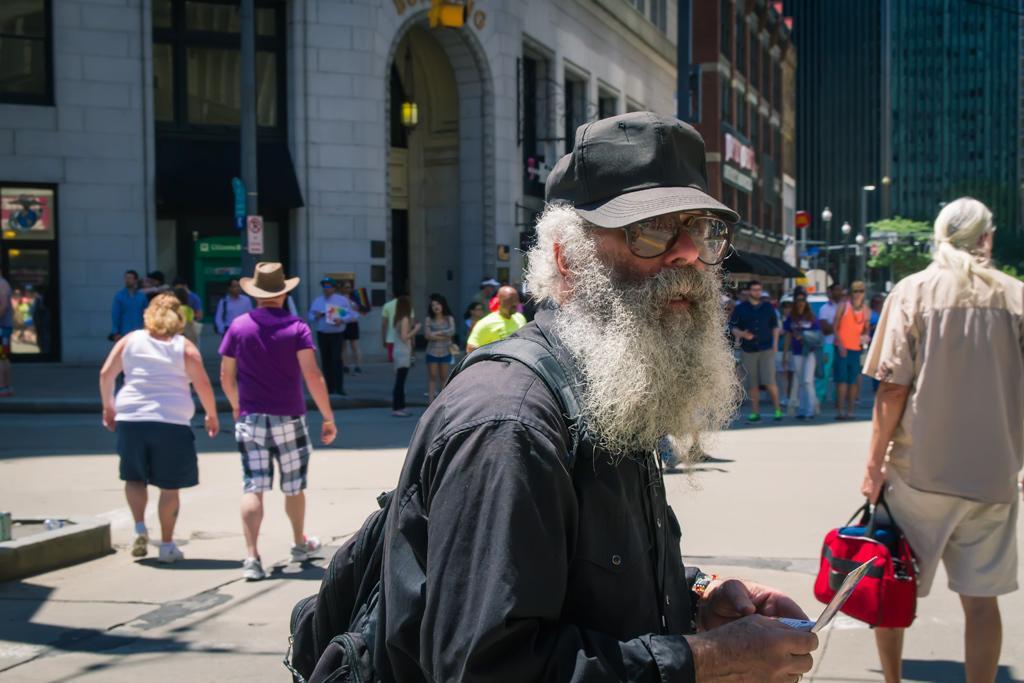How would you summarize this image in a sentence or two? In the image in the center we can see one person standing and holding some object and he is wearing a cap and backpack. On the right side of the image,there is a person standing and holding bag. In the background we can see buildings,poles,banners,sign boards,wall,few people were walking on the road,few people were holding some objects and few other objects. 